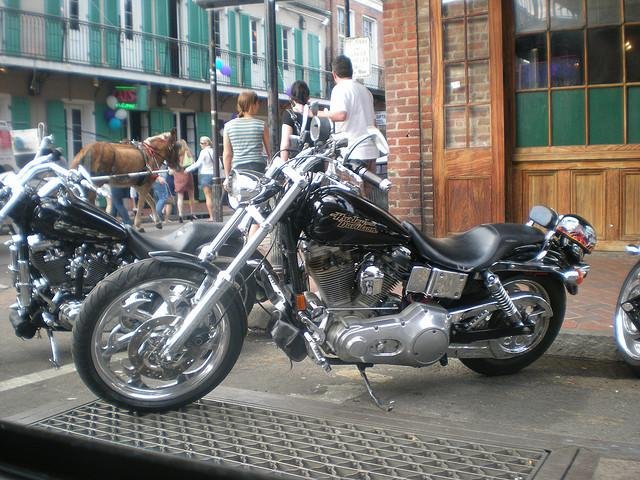What is this type of motorcycle known as?

Choices:
A) minibike
B) dirt bike
C) scooter
D) cruiser cruiser 